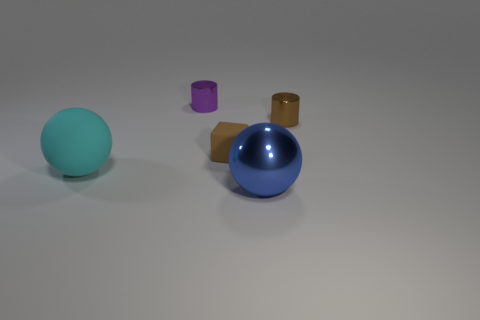What shape is the tiny metal thing that is the same color as the block?
Offer a terse response. Cylinder. Are there an equal number of large cyan spheres that are right of the cyan sphere and cyan rubber balls that are to the left of the block?
Provide a short and direct response. No. There is a brown object that is behind the matte thing that is right of the purple metal cylinder; what is its shape?
Offer a very short reply. Cylinder. There is a brown thing that is the same shape as the purple shiny thing; what is its material?
Your response must be concise. Metal. The other shiny cylinder that is the same size as the purple cylinder is what color?
Your answer should be compact. Brown. Are there an equal number of purple shiny cylinders that are to the left of the tiny purple thing and big brown metal things?
Offer a terse response. Yes. What is the color of the tiny metal thing in front of the tiny shiny cylinder on the left side of the brown rubber block?
Keep it short and to the point. Brown. How big is the ball that is right of the metallic cylinder that is left of the small brown shiny cylinder?
Offer a very short reply. Large. There is a metal cylinder that is the same color as the tiny block; what size is it?
Make the answer very short. Small. How many other things are the same size as the brown rubber thing?
Keep it short and to the point. 2. 